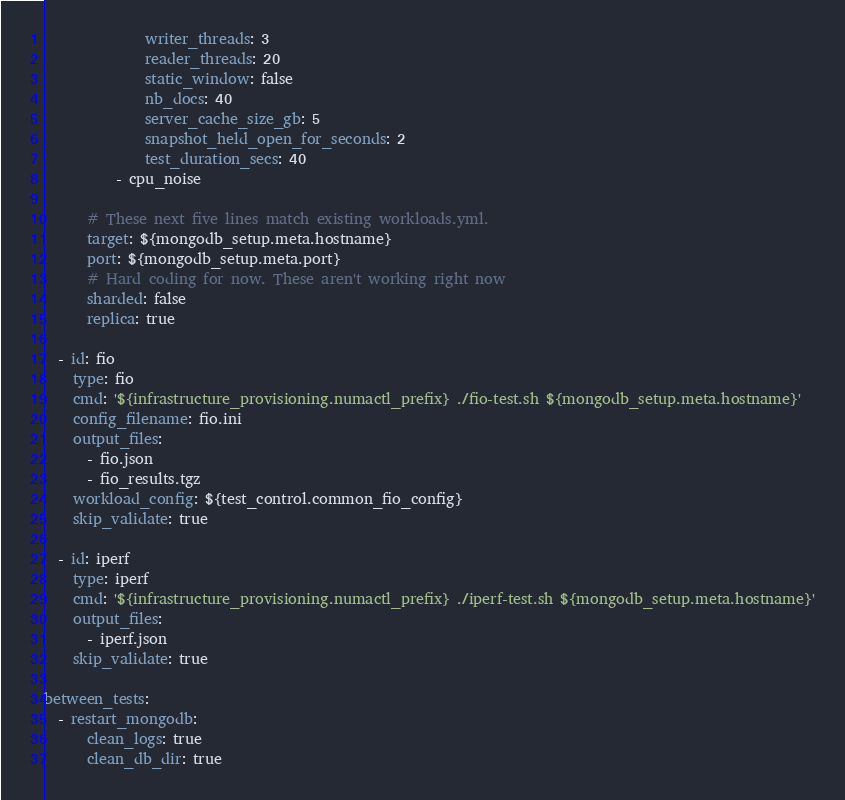<code> <loc_0><loc_0><loc_500><loc_500><_YAML_>              writer_threads: 3
              reader_threads: 20
              static_window: false
              nb_docs: 40
              server_cache_size_gb: 5
              snapshot_held_open_for_seconds: 2
              test_duration_secs: 40
          - cpu_noise

      # These next five lines match existing workloads.yml.
      target: ${mongodb_setup.meta.hostname}
      port: ${mongodb_setup.meta.port}
      # Hard coding for now. These aren't working right now
      sharded: false
      replica: true

  - id: fio
    type: fio
    cmd: '${infrastructure_provisioning.numactl_prefix} ./fio-test.sh ${mongodb_setup.meta.hostname}'
    config_filename: fio.ini
    output_files:
      - fio.json
      - fio_results.tgz
    workload_config: ${test_control.common_fio_config}
    skip_validate: true

  - id: iperf
    type: iperf
    cmd: '${infrastructure_provisioning.numactl_prefix} ./iperf-test.sh ${mongodb_setup.meta.hostname}'
    output_files:
      - iperf.json
    skip_validate: true

between_tests:
  - restart_mongodb:
      clean_logs: true
      clean_db_dir: true
</code> 